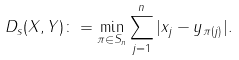<formula> <loc_0><loc_0><loc_500><loc_500>D _ { s } ( X , Y ) \colon = \min _ { \pi \in S _ { n } } \sum _ { j = 1 } ^ { n } | x _ { j } - y _ { \pi ( j ) } | .</formula> 